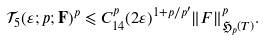<formula> <loc_0><loc_0><loc_500><loc_500>\mathcal { T } _ { 5 } ( \varepsilon ; p ; { \mathbf F } ) ^ { p } \leqslant C _ { 1 4 } ^ { p } ( 2 \varepsilon ) ^ { 1 + p / p ^ { \prime } } \| F \| ^ { p } _ { \mathfrak { H } _ { p } ( T ) } .</formula> 